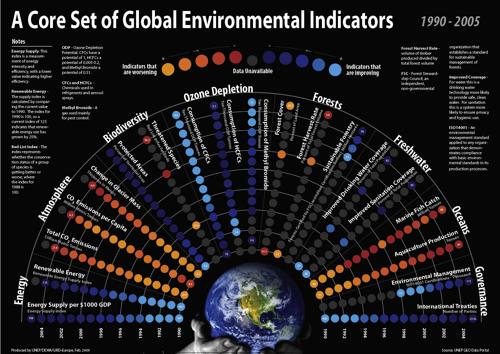Highlight a few significant elements in this photo. There are 8 global environmental indicators. 